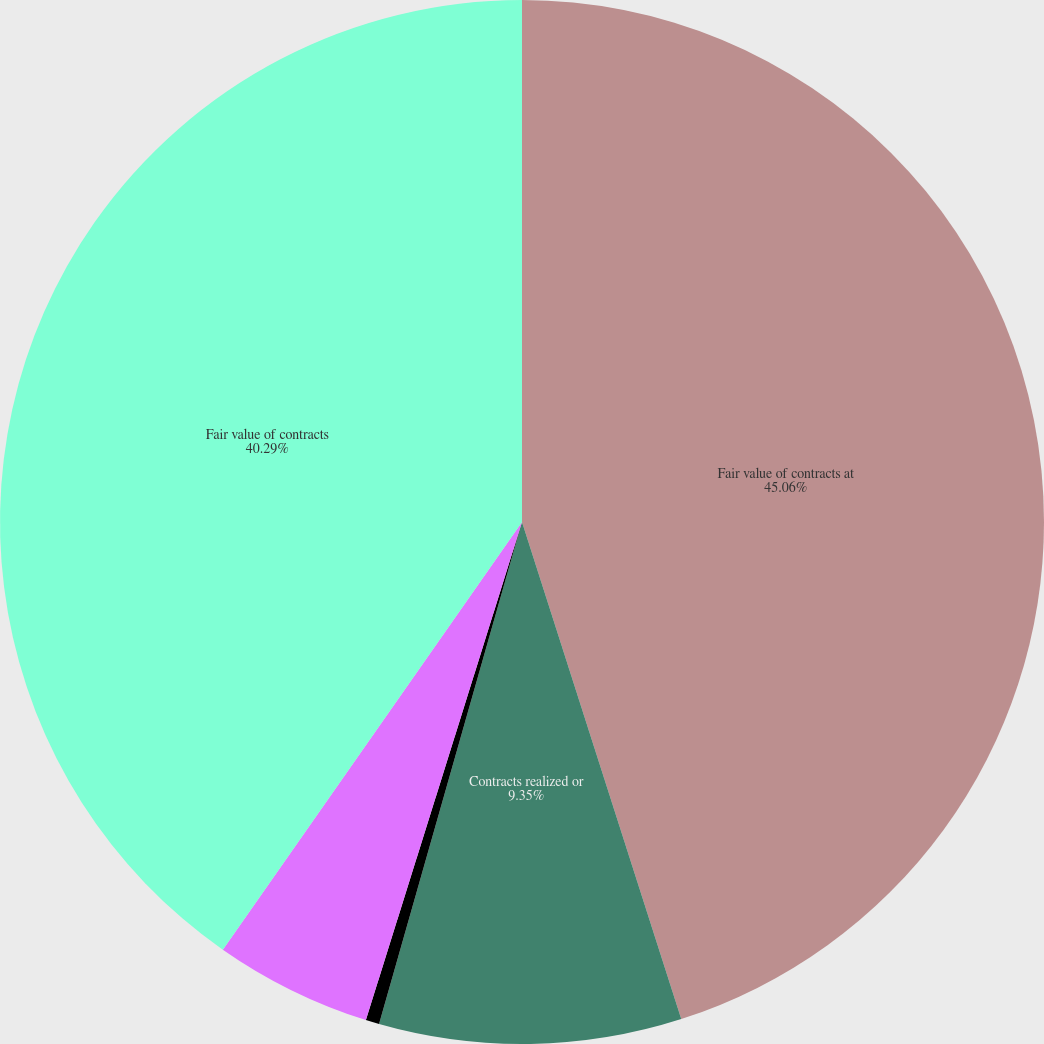Convert chart to OTSL. <chart><loc_0><loc_0><loc_500><loc_500><pie_chart><fcel>Fair value of contracts at<fcel>Contracts realized or<fcel>Fair value of new contracts<fcel>Other changes in fair value<fcel>Fair value of contracts<nl><fcel>45.07%<fcel>9.35%<fcel>0.42%<fcel>4.88%<fcel>40.29%<nl></chart> 